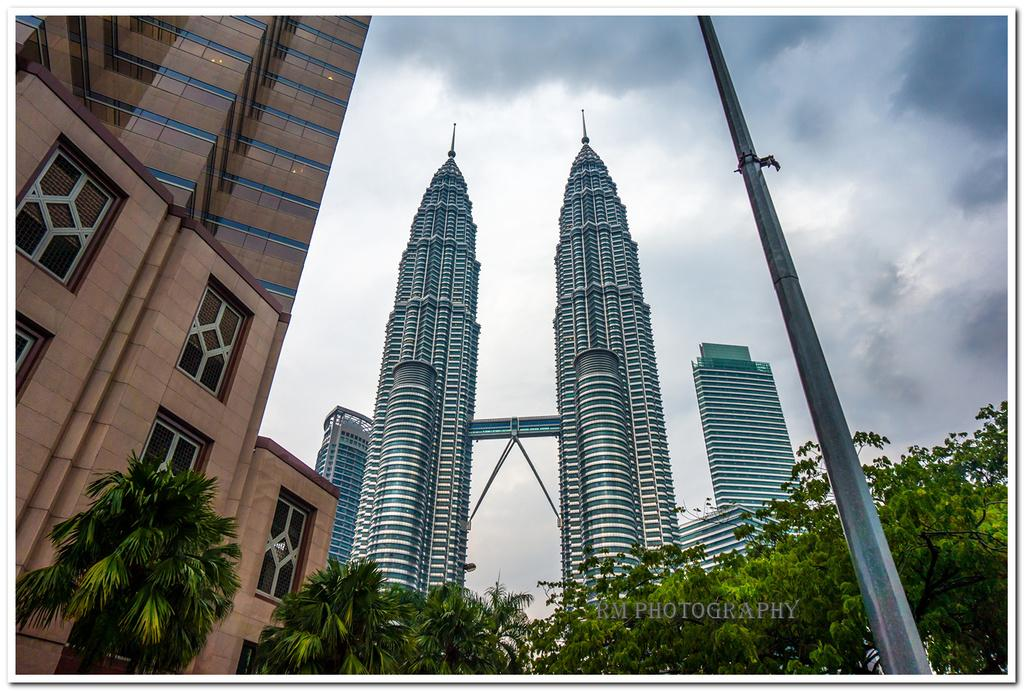What type of structures are present in the image? There are buildings in the image. What feature do the buildings have? The buildings have windows. What colors can be seen on the buildings? The buildings are in brown, white, and blue colors. What other natural elements are present in the image? There are trees in the image. What is the other object visible in the image? There is a pole in the image. What colors are visible in the sky? The sky is in white and blue colors. How many brothers are playing in the sand in the image? There are no brothers or sand present in the image. What idea is being discussed by the people in the image? There are no people or discussions visible in the image. 